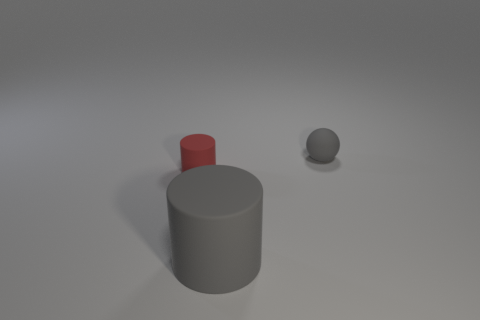Subtract all cyan cylinders. Subtract all purple spheres. How many cylinders are left? 2 Add 1 small gray matte spheres. How many objects exist? 4 Subtract all cylinders. How many objects are left? 1 Add 3 tiny brown shiny balls. How many tiny brown shiny balls exist? 3 Subtract 0 red spheres. How many objects are left? 3 Subtract all big gray matte objects. Subtract all big purple rubber spheres. How many objects are left? 2 Add 3 large objects. How many large objects are left? 4 